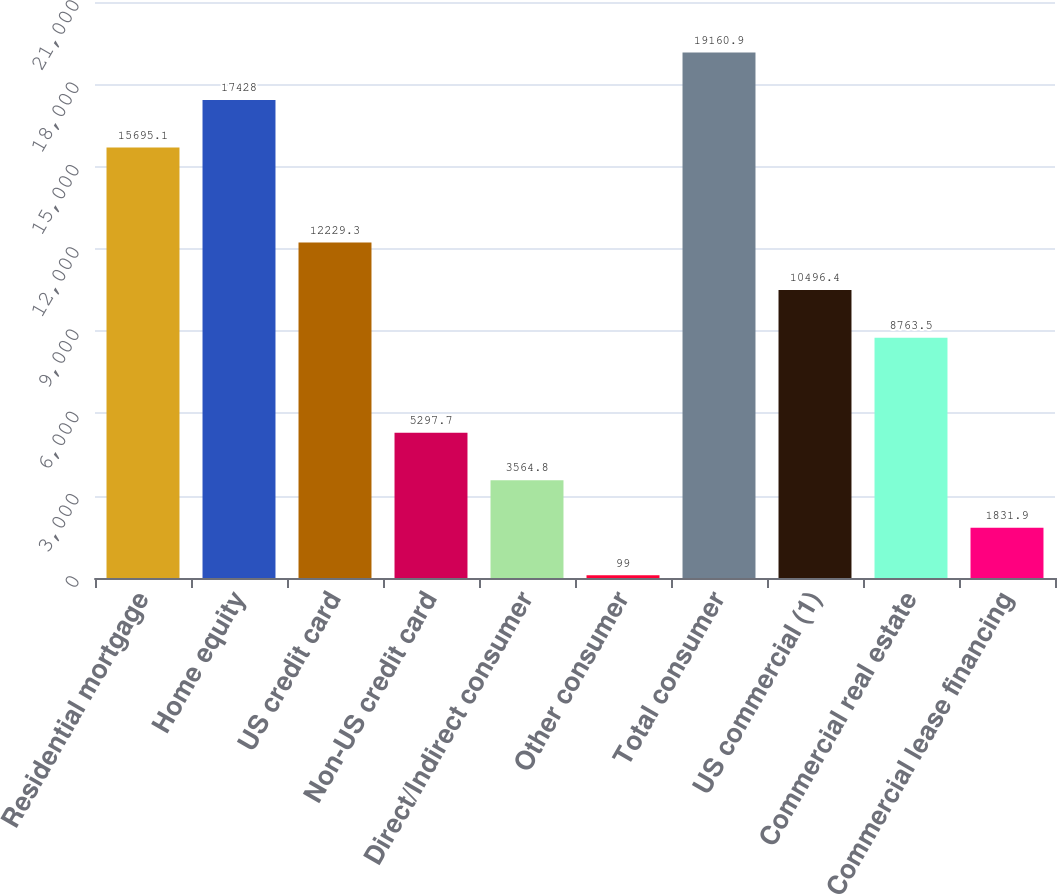<chart> <loc_0><loc_0><loc_500><loc_500><bar_chart><fcel>Residential mortgage<fcel>Home equity<fcel>US credit card<fcel>Non-US credit card<fcel>Direct/Indirect consumer<fcel>Other consumer<fcel>Total consumer<fcel>US commercial (1)<fcel>Commercial real estate<fcel>Commercial lease financing<nl><fcel>15695.1<fcel>17428<fcel>12229.3<fcel>5297.7<fcel>3564.8<fcel>99<fcel>19160.9<fcel>10496.4<fcel>8763.5<fcel>1831.9<nl></chart> 